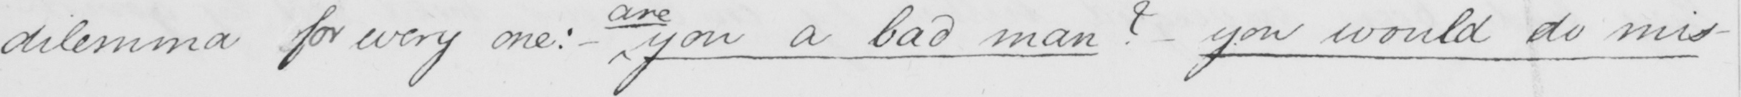What is written in this line of handwriting? dilemma for every one :   _  you a bad man  ?   _  you would do mis- 